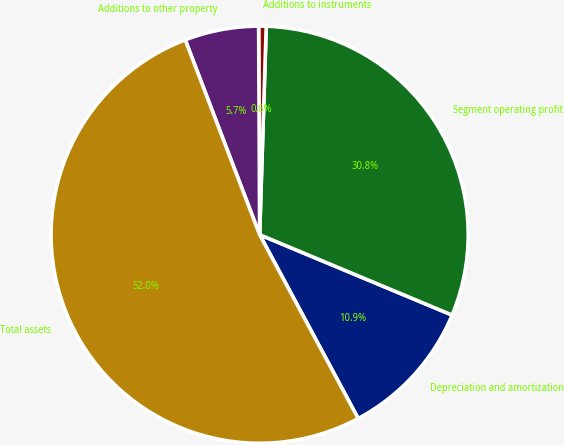<chart> <loc_0><loc_0><loc_500><loc_500><pie_chart><fcel>Depreciation and amortization<fcel>Segment operating profit<fcel>Additions to instruments<fcel>Additions to other property<fcel>Total assets<nl><fcel>10.87%<fcel>30.79%<fcel>0.58%<fcel>5.73%<fcel>52.02%<nl></chart> 